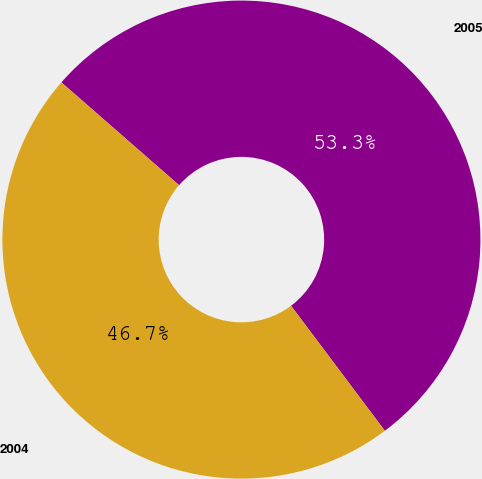<chart> <loc_0><loc_0><loc_500><loc_500><pie_chart><fcel>2005<fcel>2004<nl><fcel>53.33%<fcel>46.67%<nl></chart> 